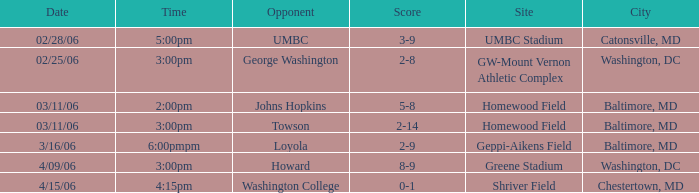Would you mind parsing the complete table? {'header': ['Date', 'Time', 'Opponent', 'Score', 'Site', 'City'], 'rows': [['02/28/06', '5:00pm', 'UMBC', '3-9', 'UMBC Stadium', 'Catonsville, MD'], ['02/25/06', '3:00pm', 'George Washington', '2-8', 'GW-Mount Vernon Athletic Complex', 'Washington, DC'], ['03/11/06', '2:00pm', 'Johns Hopkins', '5-8', 'Homewood Field', 'Baltimore, MD'], ['03/11/06', '3:00pm', 'Towson', '2-14', 'Homewood Field', 'Baltimore, MD'], ['3/16/06', '6:00pmpm', 'Loyola', '2-9', 'Geppi-Aikens Field', 'Baltimore, MD'], ['4/09/06', '3:00pm', 'Howard', '8-9', 'Greene Stadium', 'Washington, DC'], ['4/15/06', '4:15pm', 'Washington College', '0-1', 'Shriver Field', 'Chestertown, MD']]} If the venue is shriver field, what would be the corresponding date? 4/15/06. 